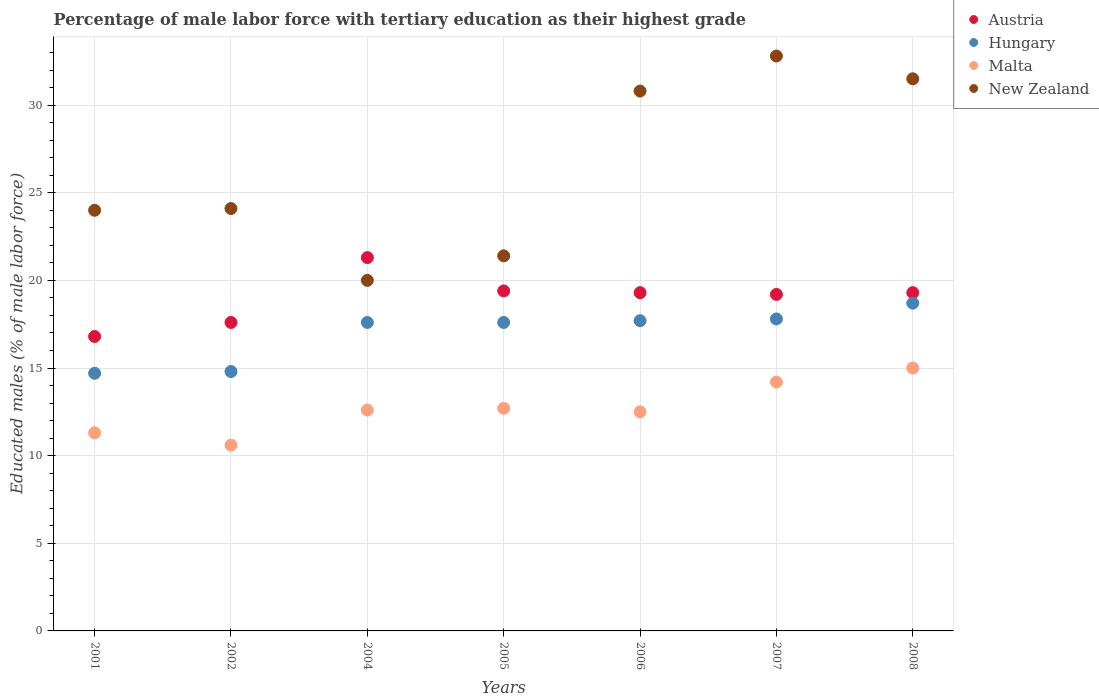What is the percentage of male labor force with tertiary education in Malta in 2005?
Provide a succinct answer. 12.7. Across all years, what is the maximum percentage of male labor force with tertiary education in Hungary?
Ensure brevity in your answer.  18.7. In which year was the percentage of male labor force with tertiary education in New Zealand maximum?
Your response must be concise. 2007. In which year was the percentage of male labor force with tertiary education in Austria minimum?
Provide a short and direct response. 2001. What is the total percentage of male labor force with tertiary education in Austria in the graph?
Give a very brief answer. 132.9. What is the difference between the percentage of male labor force with tertiary education in Hungary in 2005 and that in 2008?
Your answer should be very brief. -1.1. What is the difference between the percentage of male labor force with tertiary education in Austria in 2001 and the percentage of male labor force with tertiary education in Hungary in 2008?
Offer a very short reply. -1.9. What is the average percentage of male labor force with tertiary education in Hungary per year?
Give a very brief answer. 16.99. In the year 2002, what is the difference between the percentage of male labor force with tertiary education in Hungary and percentage of male labor force with tertiary education in Austria?
Your answer should be compact. -2.8. In how many years, is the percentage of male labor force with tertiary education in Hungary greater than 7 %?
Your answer should be compact. 7. What is the ratio of the percentage of male labor force with tertiary education in Hungary in 2002 to that in 2006?
Keep it short and to the point. 0.84. Is the difference between the percentage of male labor force with tertiary education in Hungary in 2005 and 2007 greater than the difference between the percentage of male labor force with tertiary education in Austria in 2005 and 2007?
Offer a terse response. No. What is the difference between the highest and the second highest percentage of male labor force with tertiary education in Malta?
Your answer should be compact. 0.8. What is the difference between the highest and the lowest percentage of male labor force with tertiary education in Hungary?
Offer a very short reply. 4. In how many years, is the percentage of male labor force with tertiary education in Malta greater than the average percentage of male labor force with tertiary education in Malta taken over all years?
Keep it short and to the point. 2. Is the sum of the percentage of male labor force with tertiary education in Malta in 2002 and 2007 greater than the maximum percentage of male labor force with tertiary education in New Zealand across all years?
Provide a succinct answer. No. Does the percentage of male labor force with tertiary education in Austria monotonically increase over the years?
Keep it short and to the point. No. Is the percentage of male labor force with tertiary education in Hungary strictly greater than the percentage of male labor force with tertiary education in New Zealand over the years?
Offer a very short reply. No. Is the percentage of male labor force with tertiary education in Hungary strictly less than the percentage of male labor force with tertiary education in New Zealand over the years?
Offer a very short reply. Yes. How many dotlines are there?
Provide a succinct answer. 4. How many years are there in the graph?
Ensure brevity in your answer.  7. Does the graph contain any zero values?
Give a very brief answer. No. Where does the legend appear in the graph?
Your answer should be compact. Top right. How many legend labels are there?
Offer a terse response. 4. How are the legend labels stacked?
Provide a short and direct response. Vertical. What is the title of the graph?
Your answer should be very brief. Percentage of male labor force with tertiary education as their highest grade. What is the label or title of the X-axis?
Keep it short and to the point. Years. What is the label or title of the Y-axis?
Provide a short and direct response. Educated males (% of male labor force). What is the Educated males (% of male labor force) of Austria in 2001?
Provide a succinct answer. 16.8. What is the Educated males (% of male labor force) of Hungary in 2001?
Provide a succinct answer. 14.7. What is the Educated males (% of male labor force) in Malta in 2001?
Your response must be concise. 11.3. What is the Educated males (% of male labor force) of New Zealand in 2001?
Keep it short and to the point. 24. What is the Educated males (% of male labor force) in Austria in 2002?
Provide a succinct answer. 17.6. What is the Educated males (% of male labor force) in Hungary in 2002?
Make the answer very short. 14.8. What is the Educated males (% of male labor force) of Malta in 2002?
Provide a short and direct response. 10.6. What is the Educated males (% of male labor force) of New Zealand in 2002?
Offer a very short reply. 24.1. What is the Educated males (% of male labor force) in Austria in 2004?
Offer a very short reply. 21.3. What is the Educated males (% of male labor force) in Hungary in 2004?
Give a very brief answer. 17.6. What is the Educated males (% of male labor force) of Malta in 2004?
Keep it short and to the point. 12.6. What is the Educated males (% of male labor force) of New Zealand in 2004?
Your response must be concise. 20. What is the Educated males (% of male labor force) of Austria in 2005?
Give a very brief answer. 19.4. What is the Educated males (% of male labor force) of Hungary in 2005?
Give a very brief answer. 17.6. What is the Educated males (% of male labor force) of Malta in 2005?
Give a very brief answer. 12.7. What is the Educated males (% of male labor force) in New Zealand in 2005?
Make the answer very short. 21.4. What is the Educated males (% of male labor force) of Austria in 2006?
Your response must be concise. 19.3. What is the Educated males (% of male labor force) in Hungary in 2006?
Keep it short and to the point. 17.7. What is the Educated males (% of male labor force) of New Zealand in 2006?
Provide a short and direct response. 30.8. What is the Educated males (% of male labor force) of Austria in 2007?
Provide a short and direct response. 19.2. What is the Educated males (% of male labor force) in Hungary in 2007?
Give a very brief answer. 17.8. What is the Educated males (% of male labor force) of Malta in 2007?
Keep it short and to the point. 14.2. What is the Educated males (% of male labor force) in New Zealand in 2007?
Keep it short and to the point. 32.8. What is the Educated males (% of male labor force) in Austria in 2008?
Your answer should be very brief. 19.3. What is the Educated males (% of male labor force) in Hungary in 2008?
Offer a terse response. 18.7. What is the Educated males (% of male labor force) in Malta in 2008?
Your answer should be very brief. 15. What is the Educated males (% of male labor force) of New Zealand in 2008?
Give a very brief answer. 31.5. Across all years, what is the maximum Educated males (% of male labor force) in Austria?
Give a very brief answer. 21.3. Across all years, what is the maximum Educated males (% of male labor force) of Hungary?
Ensure brevity in your answer.  18.7. Across all years, what is the maximum Educated males (% of male labor force) of Malta?
Ensure brevity in your answer.  15. Across all years, what is the maximum Educated males (% of male labor force) in New Zealand?
Provide a succinct answer. 32.8. Across all years, what is the minimum Educated males (% of male labor force) of Austria?
Provide a succinct answer. 16.8. Across all years, what is the minimum Educated males (% of male labor force) in Hungary?
Provide a succinct answer. 14.7. Across all years, what is the minimum Educated males (% of male labor force) in Malta?
Provide a short and direct response. 10.6. What is the total Educated males (% of male labor force) of Austria in the graph?
Offer a very short reply. 132.9. What is the total Educated males (% of male labor force) of Hungary in the graph?
Provide a short and direct response. 118.9. What is the total Educated males (% of male labor force) in Malta in the graph?
Provide a short and direct response. 88.9. What is the total Educated males (% of male labor force) in New Zealand in the graph?
Offer a terse response. 184.6. What is the difference between the Educated males (% of male labor force) in Austria in 2001 and that in 2002?
Ensure brevity in your answer.  -0.8. What is the difference between the Educated males (% of male labor force) in Hungary in 2001 and that in 2002?
Make the answer very short. -0.1. What is the difference between the Educated males (% of male labor force) in New Zealand in 2001 and that in 2002?
Keep it short and to the point. -0.1. What is the difference between the Educated males (% of male labor force) in Austria in 2001 and that in 2004?
Your answer should be very brief. -4.5. What is the difference between the Educated males (% of male labor force) in Malta in 2001 and that in 2005?
Keep it short and to the point. -1.4. What is the difference between the Educated males (% of male labor force) of New Zealand in 2001 and that in 2005?
Provide a succinct answer. 2.6. What is the difference between the Educated males (% of male labor force) of Austria in 2001 and that in 2006?
Ensure brevity in your answer.  -2.5. What is the difference between the Educated males (% of male labor force) of Hungary in 2001 and that in 2006?
Offer a terse response. -3. What is the difference between the Educated males (% of male labor force) of Austria in 2001 and that in 2007?
Give a very brief answer. -2.4. What is the difference between the Educated males (% of male labor force) in Malta in 2001 and that in 2007?
Provide a short and direct response. -2.9. What is the difference between the Educated males (% of male labor force) of New Zealand in 2001 and that in 2007?
Keep it short and to the point. -8.8. What is the difference between the Educated males (% of male labor force) in Austria in 2001 and that in 2008?
Your answer should be very brief. -2.5. What is the difference between the Educated males (% of male labor force) of Hungary in 2001 and that in 2008?
Offer a terse response. -4. What is the difference between the Educated males (% of male labor force) in Malta in 2002 and that in 2004?
Make the answer very short. -2. What is the difference between the Educated males (% of male labor force) of New Zealand in 2002 and that in 2004?
Keep it short and to the point. 4.1. What is the difference between the Educated males (% of male labor force) in Hungary in 2002 and that in 2005?
Ensure brevity in your answer.  -2.8. What is the difference between the Educated males (% of male labor force) of New Zealand in 2002 and that in 2005?
Your answer should be compact. 2.7. What is the difference between the Educated males (% of male labor force) in Hungary in 2002 and that in 2006?
Offer a very short reply. -2.9. What is the difference between the Educated males (% of male labor force) of New Zealand in 2002 and that in 2006?
Offer a very short reply. -6.7. What is the difference between the Educated males (% of male labor force) of Malta in 2002 and that in 2007?
Give a very brief answer. -3.6. What is the difference between the Educated males (% of male labor force) in Hungary in 2002 and that in 2008?
Keep it short and to the point. -3.9. What is the difference between the Educated males (% of male labor force) of New Zealand in 2002 and that in 2008?
Your answer should be compact. -7.4. What is the difference between the Educated males (% of male labor force) of Austria in 2004 and that in 2005?
Your answer should be compact. 1.9. What is the difference between the Educated males (% of male labor force) of Hungary in 2004 and that in 2005?
Provide a short and direct response. 0. What is the difference between the Educated males (% of male labor force) of Austria in 2004 and that in 2006?
Your response must be concise. 2. What is the difference between the Educated males (% of male labor force) of Malta in 2004 and that in 2006?
Your answer should be very brief. 0.1. What is the difference between the Educated males (% of male labor force) in New Zealand in 2004 and that in 2006?
Provide a succinct answer. -10.8. What is the difference between the Educated males (% of male labor force) of Hungary in 2004 and that in 2007?
Give a very brief answer. -0.2. What is the difference between the Educated males (% of male labor force) of New Zealand in 2004 and that in 2007?
Offer a terse response. -12.8. What is the difference between the Educated males (% of male labor force) of Austria in 2004 and that in 2008?
Your response must be concise. 2. What is the difference between the Educated males (% of male labor force) of Hungary in 2004 and that in 2008?
Give a very brief answer. -1.1. What is the difference between the Educated males (% of male labor force) of Hungary in 2005 and that in 2006?
Provide a succinct answer. -0.1. What is the difference between the Educated males (% of male labor force) of Malta in 2005 and that in 2006?
Make the answer very short. 0.2. What is the difference between the Educated males (% of male labor force) of Hungary in 2005 and that in 2007?
Your response must be concise. -0.2. What is the difference between the Educated males (% of male labor force) in New Zealand in 2005 and that in 2007?
Ensure brevity in your answer.  -11.4. What is the difference between the Educated males (% of male labor force) in Austria in 2005 and that in 2008?
Keep it short and to the point. 0.1. What is the difference between the Educated males (% of male labor force) of New Zealand in 2005 and that in 2008?
Keep it short and to the point. -10.1. What is the difference between the Educated males (% of male labor force) in Hungary in 2006 and that in 2007?
Offer a very short reply. -0.1. What is the difference between the Educated males (% of male labor force) of Austria in 2006 and that in 2008?
Offer a very short reply. 0. What is the difference between the Educated males (% of male labor force) of Austria in 2001 and the Educated males (% of male labor force) of Hungary in 2002?
Offer a very short reply. 2. What is the difference between the Educated males (% of male labor force) of Austria in 2001 and the Educated males (% of male labor force) of Malta in 2002?
Offer a terse response. 6.2. What is the difference between the Educated males (% of male labor force) in Austria in 2001 and the Educated males (% of male labor force) in Hungary in 2004?
Your answer should be compact. -0.8. What is the difference between the Educated males (% of male labor force) in Austria in 2001 and the Educated males (% of male labor force) in Malta in 2004?
Your answer should be compact. 4.2. What is the difference between the Educated males (% of male labor force) in Austria in 2001 and the Educated males (% of male labor force) in New Zealand in 2004?
Make the answer very short. -3.2. What is the difference between the Educated males (% of male labor force) of Hungary in 2001 and the Educated males (% of male labor force) of New Zealand in 2004?
Provide a short and direct response. -5.3. What is the difference between the Educated males (% of male labor force) of Malta in 2001 and the Educated males (% of male labor force) of New Zealand in 2004?
Your answer should be very brief. -8.7. What is the difference between the Educated males (% of male labor force) in Austria in 2001 and the Educated males (% of male labor force) in Malta in 2005?
Provide a succinct answer. 4.1. What is the difference between the Educated males (% of male labor force) of Austria in 2001 and the Educated males (% of male labor force) of New Zealand in 2005?
Provide a succinct answer. -4.6. What is the difference between the Educated males (% of male labor force) of Malta in 2001 and the Educated males (% of male labor force) of New Zealand in 2005?
Give a very brief answer. -10.1. What is the difference between the Educated males (% of male labor force) in Austria in 2001 and the Educated males (% of male labor force) in Malta in 2006?
Give a very brief answer. 4.3. What is the difference between the Educated males (% of male labor force) of Hungary in 2001 and the Educated males (% of male labor force) of New Zealand in 2006?
Provide a short and direct response. -16.1. What is the difference between the Educated males (% of male labor force) of Malta in 2001 and the Educated males (% of male labor force) of New Zealand in 2006?
Your answer should be very brief. -19.5. What is the difference between the Educated males (% of male labor force) of Austria in 2001 and the Educated males (% of male labor force) of Malta in 2007?
Your answer should be compact. 2.6. What is the difference between the Educated males (% of male labor force) in Hungary in 2001 and the Educated males (% of male labor force) in Malta in 2007?
Offer a very short reply. 0.5. What is the difference between the Educated males (% of male labor force) of Hungary in 2001 and the Educated males (% of male labor force) of New Zealand in 2007?
Provide a short and direct response. -18.1. What is the difference between the Educated males (% of male labor force) in Malta in 2001 and the Educated males (% of male labor force) in New Zealand in 2007?
Ensure brevity in your answer.  -21.5. What is the difference between the Educated males (% of male labor force) in Austria in 2001 and the Educated males (% of male labor force) in Malta in 2008?
Provide a short and direct response. 1.8. What is the difference between the Educated males (% of male labor force) in Austria in 2001 and the Educated males (% of male labor force) in New Zealand in 2008?
Your answer should be very brief. -14.7. What is the difference between the Educated males (% of male labor force) of Hungary in 2001 and the Educated males (% of male labor force) of New Zealand in 2008?
Provide a succinct answer. -16.8. What is the difference between the Educated males (% of male labor force) in Malta in 2001 and the Educated males (% of male labor force) in New Zealand in 2008?
Your response must be concise. -20.2. What is the difference between the Educated males (% of male labor force) in Austria in 2002 and the Educated males (% of male labor force) in Hungary in 2004?
Offer a very short reply. 0. What is the difference between the Educated males (% of male labor force) in Hungary in 2002 and the Educated males (% of male labor force) in New Zealand in 2004?
Make the answer very short. -5.2. What is the difference between the Educated males (% of male labor force) of Malta in 2002 and the Educated males (% of male labor force) of New Zealand in 2004?
Offer a terse response. -9.4. What is the difference between the Educated males (% of male labor force) in Austria in 2002 and the Educated males (% of male labor force) in Hungary in 2005?
Provide a succinct answer. 0. What is the difference between the Educated males (% of male labor force) of Austria in 2002 and the Educated males (% of male labor force) of New Zealand in 2005?
Your response must be concise. -3.8. What is the difference between the Educated males (% of male labor force) of Austria in 2002 and the Educated males (% of male labor force) of Hungary in 2006?
Provide a short and direct response. -0.1. What is the difference between the Educated males (% of male labor force) in Austria in 2002 and the Educated males (% of male labor force) in New Zealand in 2006?
Provide a short and direct response. -13.2. What is the difference between the Educated males (% of male labor force) of Hungary in 2002 and the Educated males (% of male labor force) of New Zealand in 2006?
Ensure brevity in your answer.  -16. What is the difference between the Educated males (% of male labor force) of Malta in 2002 and the Educated males (% of male labor force) of New Zealand in 2006?
Your answer should be very brief. -20.2. What is the difference between the Educated males (% of male labor force) in Austria in 2002 and the Educated males (% of male labor force) in New Zealand in 2007?
Offer a terse response. -15.2. What is the difference between the Educated males (% of male labor force) in Hungary in 2002 and the Educated males (% of male labor force) in Malta in 2007?
Your response must be concise. 0.6. What is the difference between the Educated males (% of male labor force) in Malta in 2002 and the Educated males (% of male labor force) in New Zealand in 2007?
Your answer should be compact. -22.2. What is the difference between the Educated males (% of male labor force) in Hungary in 2002 and the Educated males (% of male labor force) in Malta in 2008?
Provide a short and direct response. -0.2. What is the difference between the Educated males (% of male labor force) of Hungary in 2002 and the Educated males (% of male labor force) of New Zealand in 2008?
Keep it short and to the point. -16.7. What is the difference between the Educated males (% of male labor force) in Malta in 2002 and the Educated males (% of male labor force) in New Zealand in 2008?
Keep it short and to the point. -20.9. What is the difference between the Educated males (% of male labor force) of Austria in 2004 and the Educated males (% of male labor force) of Malta in 2005?
Make the answer very short. 8.6. What is the difference between the Educated males (% of male labor force) in Austria in 2004 and the Educated males (% of male labor force) in New Zealand in 2005?
Your response must be concise. -0.1. What is the difference between the Educated males (% of male labor force) of Hungary in 2004 and the Educated males (% of male labor force) of Malta in 2005?
Provide a succinct answer. 4.9. What is the difference between the Educated males (% of male labor force) in Malta in 2004 and the Educated males (% of male labor force) in New Zealand in 2005?
Make the answer very short. -8.8. What is the difference between the Educated males (% of male labor force) of Austria in 2004 and the Educated males (% of male labor force) of Hungary in 2006?
Keep it short and to the point. 3.6. What is the difference between the Educated males (% of male labor force) in Austria in 2004 and the Educated males (% of male labor force) in New Zealand in 2006?
Provide a succinct answer. -9.5. What is the difference between the Educated males (% of male labor force) in Hungary in 2004 and the Educated males (% of male labor force) in New Zealand in 2006?
Your response must be concise. -13.2. What is the difference between the Educated males (% of male labor force) in Malta in 2004 and the Educated males (% of male labor force) in New Zealand in 2006?
Provide a short and direct response. -18.2. What is the difference between the Educated males (% of male labor force) of Austria in 2004 and the Educated males (% of male labor force) of Malta in 2007?
Your answer should be very brief. 7.1. What is the difference between the Educated males (% of male labor force) in Hungary in 2004 and the Educated males (% of male labor force) in Malta in 2007?
Offer a terse response. 3.4. What is the difference between the Educated males (% of male labor force) of Hungary in 2004 and the Educated males (% of male labor force) of New Zealand in 2007?
Ensure brevity in your answer.  -15.2. What is the difference between the Educated males (% of male labor force) of Malta in 2004 and the Educated males (% of male labor force) of New Zealand in 2007?
Your answer should be compact. -20.2. What is the difference between the Educated males (% of male labor force) of Austria in 2004 and the Educated males (% of male labor force) of Hungary in 2008?
Provide a short and direct response. 2.6. What is the difference between the Educated males (% of male labor force) in Austria in 2004 and the Educated males (% of male labor force) in Malta in 2008?
Provide a succinct answer. 6.3. What is the difference between the Educated males (% of male labor force) of Malta in 2004 and the Educated males (% of male labor force) of New Zealand in 2008?
Provide a short and direct response. -18.9. What is the difference between the Educated males (% of male labor force) of Austria in 2005 and the Educated males (% of male labor force) of Malta in 2006?
Your response must be concise. 6.9. What is the difference between the Educated males (% of male labor force) in Austria in 2005 and the Educated males (% of male labor force) in New Zealand in 2006?
Give a very brief answer. -11.4. What is the difference between the Educated males (% of male labor force) of Hungary in 2005 and the Educated males (% of male labor force) of Malta in 2006?
Your answer should be very brief. 5.1. What is the difference between the Educated males (% of male labor force) of Hungary in 2005 and the Educated males (% of male labor force) of New Zealand in 2006?
Ensure brevity in your answer.  -13.2. What is the difference between the Educated males (% of male labor force) of Malta in 2005 and the Educated males (% of male labor force) of New Zealand in 2006?
Make the answer very short. -18.1. What is the difference between the Educated males (% of male labor force) of Austria in 2005 and the Educated males (% of male labor force) of Hungary in 2007?
Offer a terse response. 1.6. What is the difference between the Educated males (% of male labor force) of Hungary in 2005 and the Educated males (% of male labor force) of New Zealand in 2007?
Provide a short and direct response. -15.2. What is the difference between the Educated males (% of male labor force) of Malta in 2005 and the Educated males (% of male labor force) of New Zealand in 2007?
Make the answer very short. -20.1. What is the difference between the Educated males (% of male labor force) of Austria in 2005 and the Educated males (% of male labor force) of Hungary in 2008?
Provide a succinct answer. 0.7. What is the difference between the Educated males (% of male labor force) of Austria in 2005 and the Educated males (% of male labor force) of Malta in 2008?
Keep it short and to the point. 4.4. What is the difference between the Educated males (% of male labor force) of Austria in 2005 and the Educated males (% of male labor force) of New Zealand in 2008?
Keep it short and to the point. -12.1. What is the difference between the Educated males (% of male labor force) in Hungary in 2005 and the Educated males (% of male labor force) in Malta in 2008?
Your answer should be compact. 2.6. What is the difference between the Educated males (% of male labor force) in Hungary in 2005 and the Educated males (% of male labor force) in New Zealand in 2008?
Keep it short and to the point. -13.9. What is the difference between the Educated males (% of male labor force) of Malta in 2005 and the Educated males (% of male labor force) of New Zealand in 2008?
Your answer should be very brief. -18.8. What is the difference between the Educated males (% of male labor force) of Austria in 2006 and the Educated males (% of male labor force) of Hungary in 2007?
Give a very brief answer. 1.5. What is the difference between the Educated males (% of male labor force) of Austria in 2006 and the Educated males (% of male labor force) of New Zealand in 2007?
Keep it short and to the point. -13.5. What is the difference between the Educated males (% of male labor force) of Hungary in 2006 and the Educated males (% of male labor force) of New Zealand in 2007?
Make the answer very short. -15.1. What is the difference between the Educated males (% of male labor force) in Malta in 2006 and the Educated males (% of male labor force) in New Zealand in 2007?
Keep it short and to the point. -20.3. What is the difference between the Educated males (% of male labor force) in Austria in 2006 and the Educated males (% of male labor force) in Hungary in 2008?
Your answer should be very brief. 0.6. What is the difference between the Educated males (% of male labor force) in Austria in 2006 and the Educated males (% of male labor force) in Malta in 2008?
Your answer should be compact. 4.3. What is the difference between the Educated males (% of male labor force) of Austria in 2006 and the Educated males (% of male labor force) of New Zealand in 2008?
Your answer should be very brief. -12.2. What is the difference between the Educated males (% of male labor force) of Hungary in 2006 and the Educated males (% of male labor force) of Malta in 2008?
Your answer should be compact. 2.7. What is the difference between the Educated males (% of male labor force) of Austria in 2007 and the Educated males (% of male labor force) of Hungary in 2008?
Make the answer very short. 0.5. What is the difference between the Educated males (% of male labor force) of Austria in 2007 and the Educated males (% of male labor force) of Malta in 2008?
Provide a short and direct response. 4.2. What is the difference between the Educated males (% of male labor force) of Hungary in 2007 and the Educated males (% of male labor force) of New Zealand in 2008?
Ensure brevity in your answer.  -13.7. What is the difference between the Educated males (% of male labor force) of Malta in 2007 and the Educated males (% of male labor force) of New Zealand in 2008?
Your response must be concise. -17.3. What is the average Educated males (% of male labor force) of Austria per year?
Provide a short and direct response. 18.99. What is the average Educated males (% of male labor force) of Hungary per year?
Offer a terse response. 16.99. What is the average Educated males (% of male labor force) in New Zealand per year?
Keep it short and to the point. 26.37. In the year 2001, what is the difference between the Educated males (% of male labor force) in Hungary and Educated males (% of male labor force) in Malta?
Make the answer very short. 3.4. In the year 2001, what is the difference between the Educated males (% of male labor force) in Hungary and Educated males (% of male labor force) in New Zealand?
Offer a terse response. -9.3. In the year 2002, what is the difference between the Educated males (% of male labor force) of Austria and Educated males (% of male labor force) of Hungary?
Provide a short and direct response. 2.8. In the year 2002, what is the difference between the Educated males (% of male labor force) in Austria and Educated males (% of male labor force) in New Zealand?
Give a very brief answer. -6.5. In the year 2002, what is the difference between the Educated males (% of male labor force) in Hungary and Educated males (% of male labor force) in Malta?
Provide a succinct answer. 4.2. In the year 2002, what is the difference between the Educated males (% of male labor force) in Hungary and Educated males (% of male labor force) in New Zealand?
Keep it short and to the point. -9.3. In the year 2002, what is the difference between the Educated males (% of male labor force) of Malta and Educated males (% of male labor force) of New Zealand?
Provide a short and direct response. -13.5. In the year 2004, what is the difference between the Educated males (% of male labor force) of Austria and Educated males (% of male labor force) of Malta?
Make the answer very short. 8.7. In the year 2004, what is the difference between the Educated males (% of male labor force) of Austria and Educated males (% of male labor force) of New Zealand?
Your response must be concise. 1.3. In the year 2004, what is the difference between the Educated males (% of male labor force) of Hungary and Educated males (% of male labor force) of Malta?
Offer a very short reply. 5. In the year 2004, what is the difference between the Educated males (% of male labor force) in Malta and Educated males (% of male labor force) in New Zealand?
Offer a terse response. -7.4. In the year 2005, what is the difference between the Educated males (% of male labor force) in Austria and Educated males (% of male labor force) in Malta?
Make the answer very short. 6.7. In the year 2005, what is the difference between the Educated males (% of male labor force) in Austria and Educated males (% of male labor force) in New Zealand?
Ensure brevity in your answer.  -2. In the year 2005, what is the difference between the Educated males (% of male labor force) of Hungary and Educated males (% of male labor force) of New Zealand?
Give a very brief answer. -3.8. In the year 2005, what is the difference between the Educated males (% of male labor force) of Malta and Educated males (% of male labor force) of New Zealand?
Keep it short and to the point. -8.7. In the year 2006, what is the difference between the Educated males (% of male labor force) in Austria and Educated males (% of male labor force) in Malta?
Your answer should be compact. 6.8. In the year 2006, what is the difference between the Educated males (% of male labor force) in Hungary and Educated males (% of male labor force) in Malta?
Your answer should be compact. 5.2. In the year 2006, what is the difference between the Educated males (% of male labor force) of Malta and Educated males (% of male labor force) of New Zealand?
Offer a terse response. -18.3. In the year 2007, what is the difference between the Educated males (% of male labor force) of Austria and Educated males (% of male labor force) of Malta?
Ensure brevity in your answer.  5. In the year 2007, what is the difference between the Educated males (% of male labor force) of Austria and Educated males (% of male labor force) of New Zealand?
Your response must be concise. -13.6. In the year 2007, what is the difference between the Educated males (% of male labor force) in Malta and Educated males (% of male labor force) in New Zealand?
Give a very brief answer. -18.6. In the year 2008, what is the difference between the Educated males (% of male labor force) of Austria and Educated males (% of male labor force) of Hungary?
Keep it short and to the point. 0.6. In the year 2008, what is the difference between the Educated males (% of male labor force) of Austria and Educated males (% of male labor force) of New Zealand?
Give a very brief answer. -12.2. In the year 2008, what is the difference between the Educated males (% of male labor force) of Hungary and Educated males (% of male labor force) of New Zealand?
Offer a terse response. -12.8. In the year 2008, what is the difference between the Educated males (% of male labor force) of Malta and Educated males (% of male labor force) of New Zealand?
Make the answer very short. -16.5. What is the ratio of the Educated males (% of male labor force) in Austria in 2001 to that in 2002?
Offer a very short reply. 0.95. What is the ratio of the Educated males (% of male labor force) of Malta in 2001 to that in 2002?
Your answer should be compact. 1.07. What is the ratio of the Educated males (% of male labor force) of Austria in 2001 to that in 2004?
Keep it short and to the point. 0.79. What is the ratio of the Educated males (% of male labor force) of Hungary in 2001 to that in 2004?
Keep it short and to the point. 0.84. What is the ratio of the Educated males (% of male labor force) of Malta in 2001 to that in 2004?
Make the answer very short. 0.9. What is the ratio of the Educated males (% of male labor force) in Austria in 2001 to that in 2005?
Make the answer very short. 0.87. What is the ratio of the Educated males (% of male labor force) in Hungary in 2001 to that in 2005?
Keep it short and to the point. 0.84. What is the ratio of the Educated males (% of male labor force) in Malta in 2001 to that in 2005?
Your answer should be very brief. 0.89. What is the ratio of the Educated males (% of male labor force) of New Zealand in 2001 to that in 2005?
Your response must be concise. 1.12. What is the ratio of the Educated males (% of male labor force) in Austria in 2001 to that in 2006?
Provide a short and direct response. 0.87. What is the ratio of the Educated males (% of male labor force) of Hungary in 2001 to that in 2006?
Your answer should be very brief. 0.83. What is the ratio of the Educated males (% of male labor force) of Malta in 2001 to that in 2006?
Offer a very short reply. 0.9. What is the ratio of the Educated males (% of male labor force) of New Zealand in 2001 to that in 2006?
Make the answer very short. 0.78. What is the ratio of the Educated males (% of male labor force) of Hungary in 2001 to that in 2007?
Provide a short and direct response. 0.83. What is the ratio of the Educated males (% of male labor force) of Malta in 2001 to that in 2007?
Provide a short and direct response. 0.8. What is the ratio of the Educated males (% of male labor force) of New Zealand in 2001 to that in 2007?
Ensure brevity in your answer.  0.73. What is the ratio of the Educated males (% of male labor force) in Austria in 2001 to that in 2008?
Your answer should be compact. 0.87. What is the ratio of the Educated males (% of male labor force) of Hungary in 2001 to that in 2008?
Your answer should be compact. 0.79. What is the ratio of the Educated males (% of male labor force) in Malta in 2001 to that in 2008?
Give a very brief answer. 0.75. What is the ratio of the Educated males (% of male labor force) in New Zealand in 2001 to that in 2008?
Make the answer very short. 0.76. What is the ratio of the Educated males (% of male labor force) of Austria in 2002 to that in 2004?
Provide a succinct answer. 0.83. What is the ratio of the Educated males (% of male labor force) in Hungary in 2002 to that in 2004?
Provide a succinct answer. 0.84. What is the ratio of the Educated males (% of male labor force) in Malta in 2002 to that in 2004?
Keep it short and to the point. 0.84. What is the ratio of the Educated males (% of male labor force) of New Zealand in 2002 to that in 2004?
Your response must be concise. 1.21. What is the ratio of the Educated males (% of male labor force) of Austria in 2002 to that in 2005?
Provide a succinct answer. 0.91. What is the ratio of the Educated males (% of male labor force) in Hungary in 2002 to that in 2005?
Offer a very short reply. 0.84. What is the ratio of the Educated males (% of male labor force) in Malta in 2002 to that in 2005?
Provide a succinct answer. 0.83. What is the ratio of the Educated males (% of male labor force) of New Zealand in 2002 to that in 2005?
Provide a short and direct response. 1.13. What is the ratio of the Educated males (% of male labor force) in Austria in 2002 to that in 2006?
Your answer should be compact. 0.91. What is the ratio of the Educated males (% of male labor force) of Hungary in 2002 to that in 2006?
Provide a short and direct response. 0.84. What is the ratio of the Educated males (% of male labor force) of Malta in 2002 to that in 2006?
Make the answer very short. 0.85. What is the ratio of the Educated males (% of male labor force) in New Zealand in 2002 to that in 2006?
Give a very brief answer. 0.78. What is the ratio of the Educated males (% of male labor force) of Austria in 2002 to that in 2007?
Offer a terse response. 0.92. What is the ratio of the Educated males (% of male labor force) in Hungary in 2002 to that in 2007?
Give a very brief answer. 0.83. What is the ratio of the Educated males (% of male labor force) of Malta in 2002 to that in 2007?
Make the answer very short. 0.75. What is the ratio of the Educated males (% of male labor force) in New Zealand in 2002 to that in 2007?
Your answer should be very brief. 0.73. What is the ratio of the Educated males (% of male labor force) in Austria in 2002 to that in 2008?
Offer a very short reply. 0.91. What is the ratio of the Educated males (% of male labor force) in Hungary in 2002 to that in 2008?
Give a very brief answer. 0.79. What is the ratio of the Educated males (% of male labor force) of Malta in 2002 to that in 2008?
Offer a very short reply. 0.71. What is the ratio of the Educated males (% of male labor force) of New Zealand in 2002 to that in 2008?
Offer a very short reply. 0.77. What is the ratio of the Educated males (% of male labor force) of Austria in 2004 to that in 2005?
Provide a succinct answer. 1.1. What is the ratio of the Educated males (% of male labor force) of New Zealand in 2004 to that in 2005?
Keep it short and to the point. 0.93. What is the ratio of the Educated males (% of male labor force) in Austria in 2004 to that in 2006?
Provide a succinct answer. 1.1. What is the ratio of the Educated males (% of male labor force) in Hungary in 2004 to that in 2006?
Your answer should be compact. 0.99. What is the ratio of the Educated males (% of male labor force) of New Zealand in 2004 to that in 2006?
Provide a short and direct response. 0.65. What is the ratio of the Educated males (% of male labor force) in Austria in 2004 to that in 2007?
Make the answer very short. 1.11. What is the ratio of the Educated males (% of male labor force) of Hungary in 2004 to that in 2007?
Your answer should be compact. 0.99. What is the ratio of the Educated males (% of male labor force) of Malta in 2004 to that in 2007?
Offer a very short reply. 0.89. What is the ratio of the Educated males (% of male labor force) of New Zealand in 2004 to that in 2007?
Your response must be concise. 0.61. What is the ratio of the Educated males (% of male labor force) in Austria in 2004 to that in 2008?
Provide a succinct answer. 1.1. What is the ratio of the Educated males (% of male labor force) in Hungary in 2004 to that in 2008?
Provide a succinct answer. 0.94. What is the ratio of the Educated males (% of male labor force) of Malta in 2004 to that in 2008?
Make the answer very short. 0.84. What is the ratio of the Educated males (% of male labor force) of New Zealand in 2004 to that in 2008?
Your response must be concise. 0.63. What is the ratio of the Educated males (% of male labor force) of Austria in 2005 to that in 2006?
Give a very brief answer. 1.01. What is the ratio of the Educated males (% of male labor force) of Hungary in 2005 to that in 2006?
Make the answer very short. 0.99. What is the ratio of the Educated males (% of male labor force) in New Zealand in 2005 to that in 2006?
Your answer should be very brief. 0.69. What is the ratio of the Educated males (% of male labor force) in Austria in 2005 to that in 2007?
Provide a short and direct response. 1.01. What is the ratio of the Educated males (% of male labor force) in Hungary in 2005 to that in 2007?
Provide a succinct answer. 0.99. What is the ratio of the Educated males (% of male labor force) of Malta in 2005 to that in 2007?
Provide a succinct answer. 0.89. What is the ratio of the Educated males (% of male labor force) in New Zealand in 2005 to that in 2007?
Provide a short and direct response. 0.65. What is the ratio of the Educated males (% of male labor force) of Austria in 2005 to that in 2008?
Your response must be concise. 1.01. What is the ratio of the Educated males (% of male labor force) of Hungary in 2005 to that in 2008?
Your answer should be compact. 0.94. What is the ratio of the Educated males (% of male labor force) in Malta in 2005 to that in 2008?
Ensure brevity in your answer.  0.85. What is the ratio of the Educated males (% of male labor force) of New Zealand in 2005 to that in 2008?
Your answer should be very brief. 0.68. What is the ratio of the Educated males (% of male labor force) of Austria in 2006 to that in 2007?
Your response must be concise. 1.01. What is the ratio of the Educated males (% of male labor force) of Hungary in 2006 to that in 2007?
Keep it short and to the point. 0.99. What is the ratio of the Educated males (% of male labor force) of Malta in 2006 to that in 2007?
Make the answer very short. 0.88. What is the ratio of the Educated males (% of male labor force) in New Zealand in 2006 to that in 2007?
Keep it short and to the point. 0.94. What is the ratio of the Educated males (% of male labor force) of Hungary in 2006 to that in 2008?
Give a very brief answer. 0.95. What is the ratio of the Educated males (% of male labor force) in New Zealand in 2006 to that in 2008?
Keep it short and to the point. 0.98. What is the ratio of the Educated males (% of male labor force) in Hungary in 2007 to that in 2008?
Keep it short and to the point. 0.95. What is the ratio of the Educated males (% of male labor force) in Malta in 2007 to that in 2008?
Your response must be concise. 0.95. What is the ratio of the Educated males (% of male labor force) of New Zealand in 2007 to that in 2008?
Provide a short and direct response. 1.04. What is the difference between the highest and the second highest Educated males (% of male labor force) in Austria?
Your answer should be very brief. 1.9. What is the difference between the highest and the second highest Educated males (% of male labor force) in Hungary?
Keep it short and to the point. 0.9. What is the difference between the highest and the second highest Educated males (% of male labor force) in Malta?
Your answer should be compact. 0.8. What is the difference between the highest and the lowest Educated males (% of male labor force) in Austria?
Keep it short and to the point. 4.5. What is the difference between the highest and the lowest Educated males (% of male labor force) of Malta?
Your answer should be compact. 4.4. What is the difference between the highest and the lowest Educated males (% of male labor force) in New Zealand?
Your answer should be compact. 12.8. 